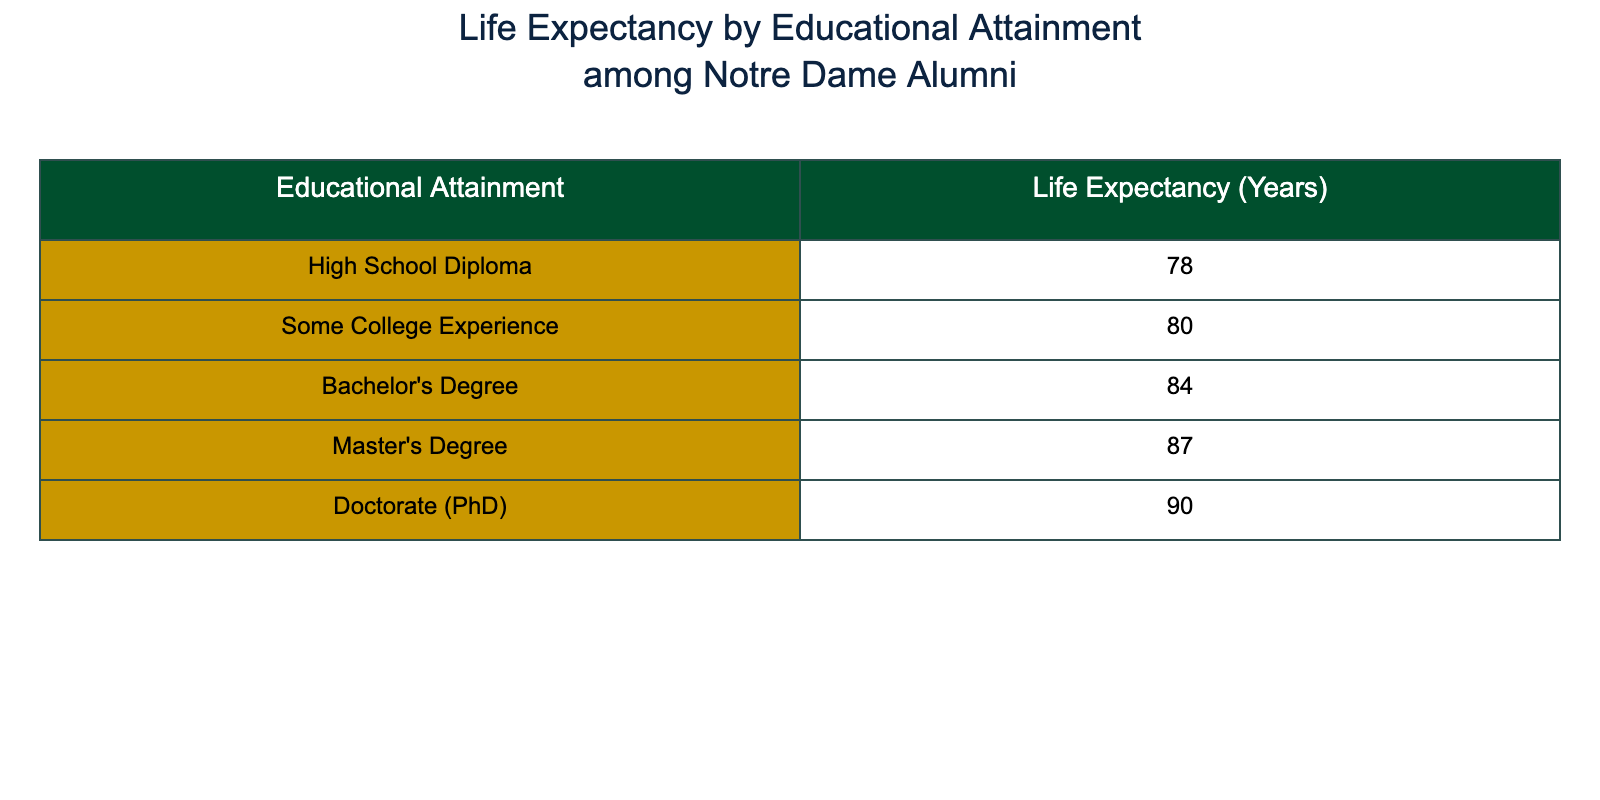What is the life expectancy for those with a Doctorate (PhD)? The table states that the life expectancy for individuals with a Doctorate (PhD) is listed directly under that category. Referring to the table, it shows the value is 90 years.
Answer: 90 What educational attainment category has the lowest life expectancy? By examining the life expectancy values listed, it is evident that the "High School Diploma" category has the lowest life expectancy at 78 years, as it is the first listed value in the table.
Answer: High School Diploma What is the difference in life expectancy between those with a Bachelor's Degree and Master's Degree? Looking at the life expectancies, the Bachelor's Degree has a life expectancy of 84 years, while the Master's Degree has 87 years. The difference is calculated by subtracting the lower from the higher: 87 - 84 = 3.
Answer: 3 Is it true that individuals with a Master's Degree have a higher life expectancy than those with a Bachelor's Degree? Comparing the life expectancies, 87 years for a Master's Degree is indeed greater than 84 years for a Bachelor's Degree. This confirms the statement is true.
Answer: Yes What is the average life expectancy of Notre Dame alumni with some college experience and a Bachelor's Degree? To find the average, first, the life expectancies for "Some College Experience" (80 years) and "Bachelor's Degree" (84 years) need to be summed. 80 + 84 = 164. Next, divide by 2: 164 / 2 = 82.
Answer: 82 Which educational attainment category has the highest life expectancy? By reviewing the table, it is clear that the "Doctorate (PhD)" category has the highest life expectancy, listed as 90 years, which is more than all other listed categories.
Answer: Doctorate (PhD) What is the life expectancy for Notre Dame alumni who have only some college experience? The life expectancy for that category is directly found in the table and is shown as 80 years.
Answer: 80 What is the range of life expectancy across all educational attainments listed? The range is found by taking the highest life expectancy (90 years for Doctorate) and subtracting the lowest (78 years for High School Diploma). The calculation is 90 - 78 = 12.
Answer: 12 